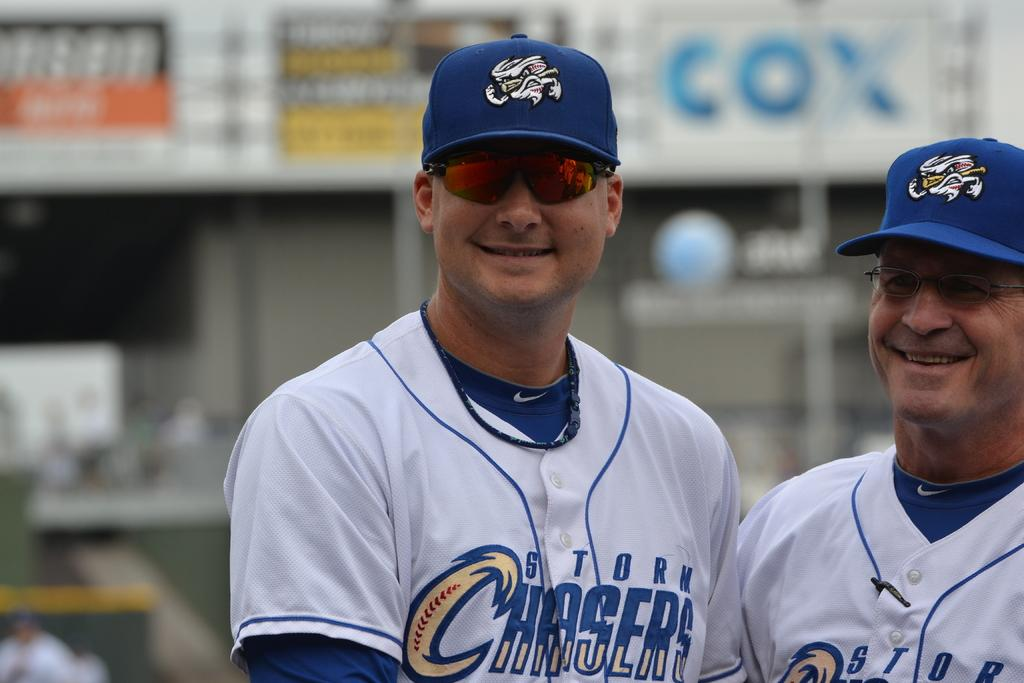<image>
Provide a brief description of the given image. Baseball player with sunglasses on and Storm Chasers on his uniform. 